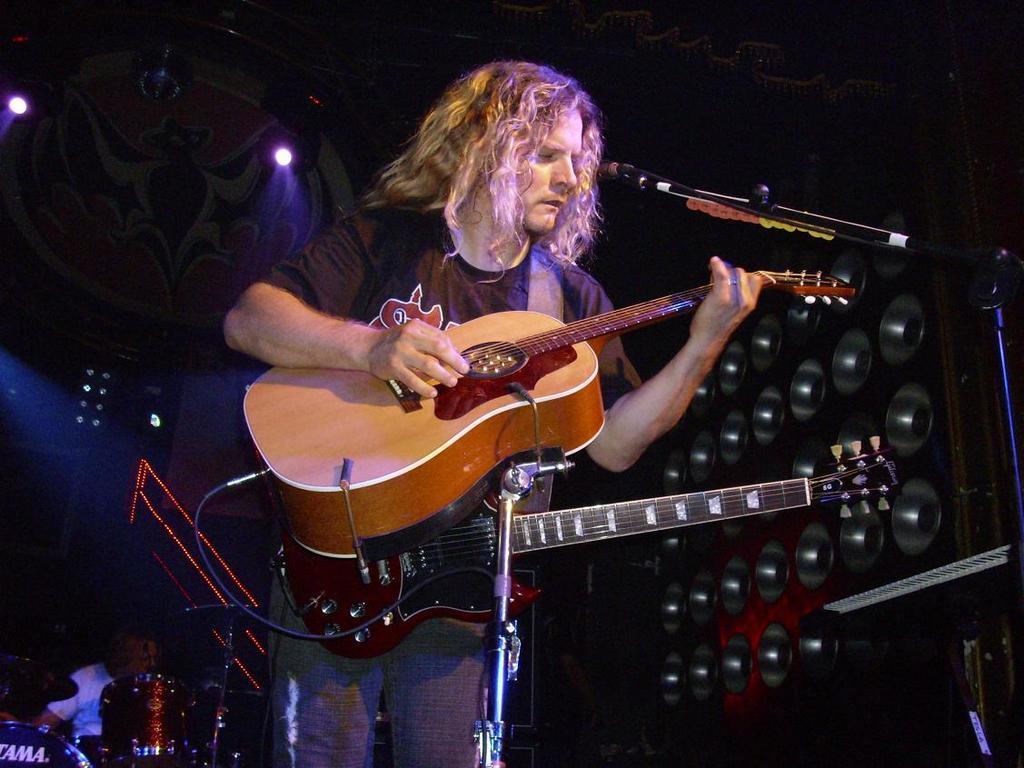How would you summarize this image in a sentence or two? This picture shows a man standing and playing guitar 